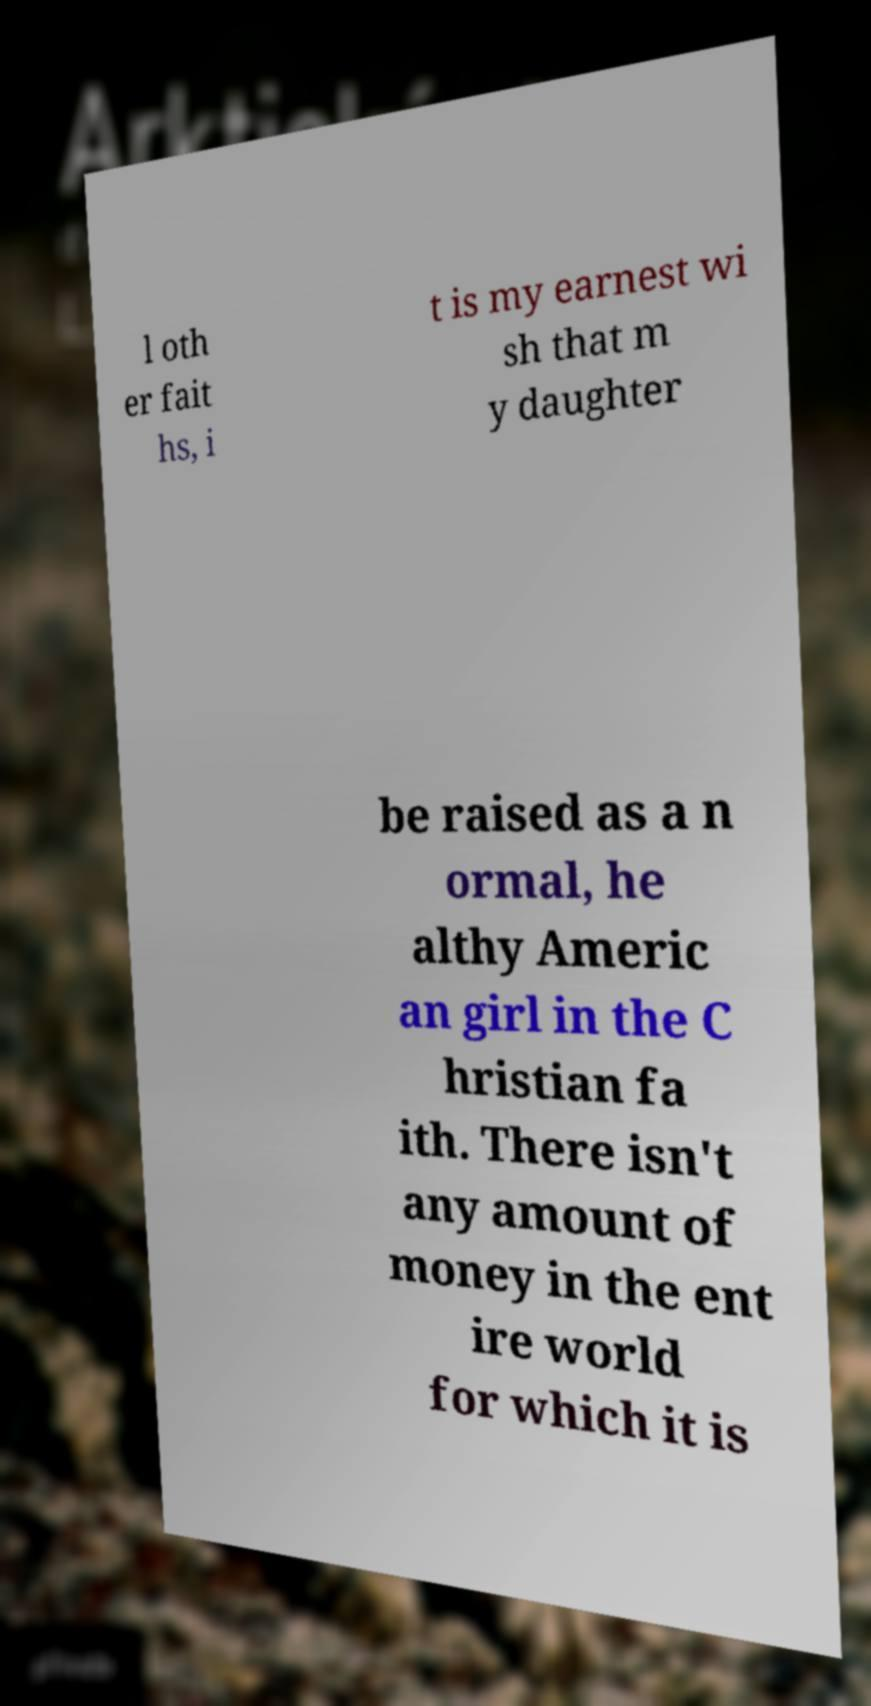For documentation purposes, I need the text within this image transcribed. Could you provide that? l oth er fait hs, i t is my earnest wi sh that m y daughter be raised as a n ormal, he althy Americ an girl in the C hristian fa ith. There isn't any amount of money in the ent ire world for which it is 